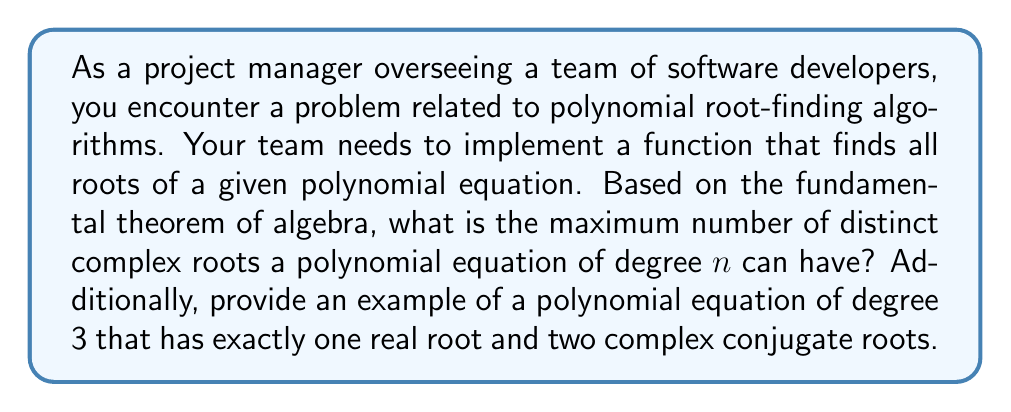Give your solution to this math problem. Let's approach this step-by-step:

1) The Fundamental Theorem of Algebra states that every non-constant single-variable polynomial with complex coefficients has at least one complex root.

2) This theorem implies that a polynomial of degree $n$ has exactly $n$ complex roots when counted with multiplicity.

3) The maximum number of distinct roots occurs when all roots have multiplicity 1.

4) Therefore, the maximum number of distinct complex roots a polynomial equation of degree $n$ can have is $n$.

5) For the example of a polynomial equation of degree 3 with exactly one real root and two complex conjugate roots, we can construct one as follows:

   Let's start with the factors $(x - 1)(x - i)(x + i)$

6) Expanding this:
   $$(x - 1)(x - i)(x + i) = (x - 1)(x^2 + 1)$$
   $$= x^3 - x^2 + x - 1$$

7) So, the polynomial equation $x^3 - x^2 + x - 1 = 0$ has:
   - One real root: $x = 1$
   - Two complex conjugate roots: $x = i$ and $x = -i$

This polynomial satisfies our requirements.
Answer: $n$ distinct roots; $x^3 - x^2 + x - 1 = 0$ 